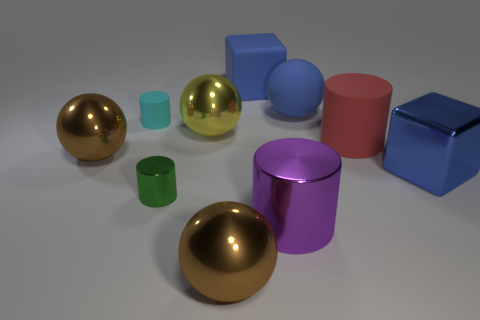Subtract all yellow spheres. How many spheres are left? 3 Subtract all brown blocks. How many brown spheres are left? 2 Subtract 1 blocks. How many blocks are left? 1 Subtract all red cylinders. How many cylinders are left? 3 Subtract 0 cyan blocks. How many objects are left? 10 Subtract all cylinders. How many objects are left? 6 Subtract all red cylinders. Subtract all brown balls. How many cylinders are left? 3 Subtract all yellow metallic things. Subtract all small green cylinders. How many objects are left? 8 Add 9 yellow balls. How many yellow balls are left? 10 Add 4 cylinders. How many cylinders exist? 8 